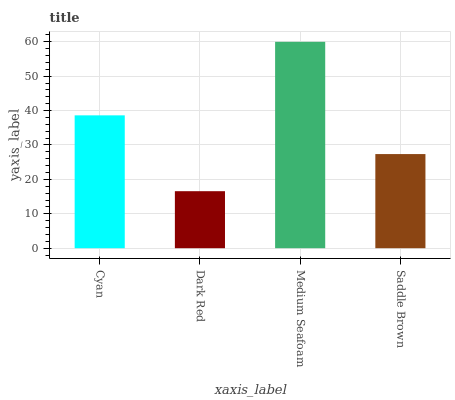Is Dark Red the minimum?
Answer yes or no. Yes. Is Medium Seafoam the maximum?
Answer yes or no. Yes. Is Medium Seafoam the minimum?
Answer yes or no. No. Is Dark Red the maximum?
Answer yes or no. No. Is Medium Seafoam greater than Dark Red?
Answer yes or no. Yes. Is Dark Red less than Medium Seafoam?
Answer yes or no. Yes. Is Dark Red greater than Medium Seafoam?
Answer yes or no. No. Is Medium Seafoam less than Dark Red?
Answer yes or no. No. Is Cyan the high median?
Answer yes or no. Yes. Is Saddle Brown the low median?
Answer yes or no. Yes. Is Dark Red the high median?
Answer yes or no. No. Is Medium Seafoam the low median?
Answer yes or no. No. 